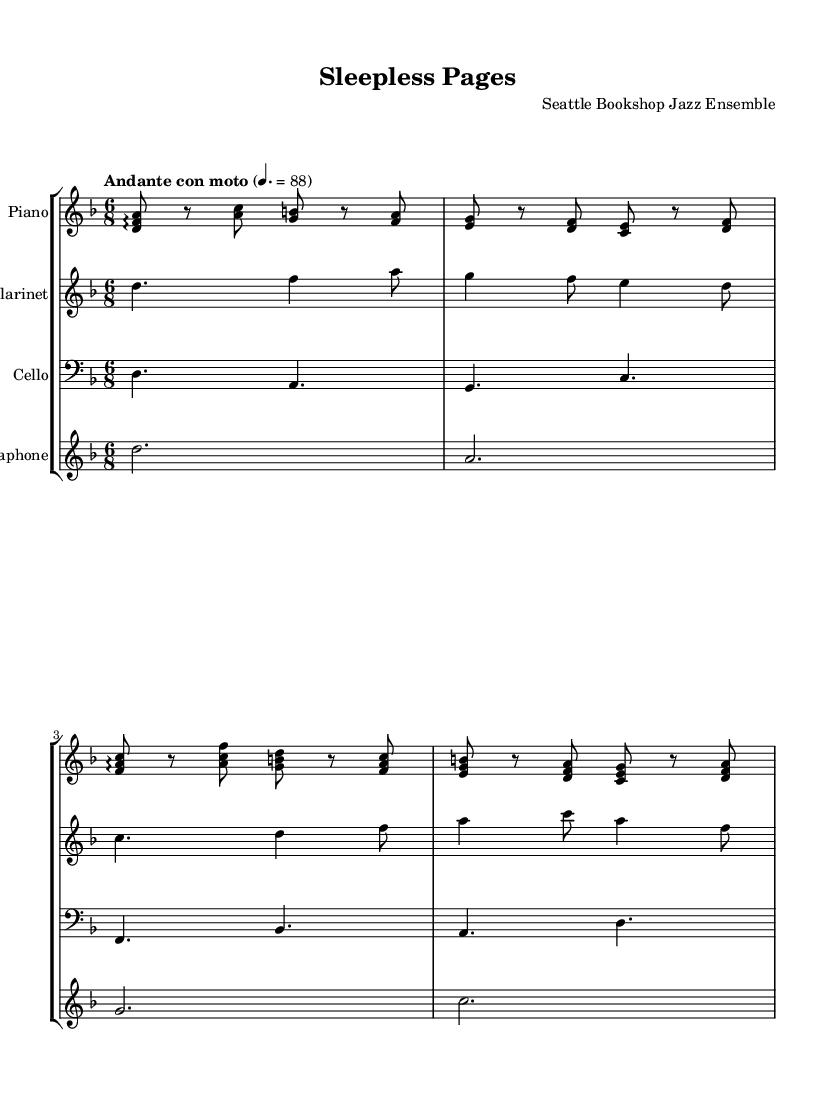What is the key signature of this music? The key signature shows one flat, indicating that the music is in the key of D minor.
Answer: D minor What is the time signature? The time signature is located at the beginning of the score and displayed as 6/8, indicating six eighth notes per measure.
Answer: 6/8 What is the tempo marking? The tempo marking is indicated above the staff and reads "Andante con moto," which means a moderately slow tempo with motion.
Answer: Andante con moto How many instruments are featured in this piece? The score includes four distinct staves, each representing a different instrument: piano, clarinet, cello, and vibraphone.
Answer: Four Which instrument has the highest pitch range? The clarinet is the highest-pitched instrument in the score, as it is written in the treble clef and plays notes in the upper register compared to the others.
Answer: Clarinet Which instrument plays the longest note duration? The vibraphone holds whole notes (dotted half notes) throughout its part, indicating it plays the longest sustained notes in the ensemble.
Answer: Vibraphone What texture does the music create with the specified instrumentation? The combination of instruments creates a lush, layered texture typical of jazz-classical fusion, where the piano provides harmonic support, the clarinet offers melodic lines, the cello plays bass, and the vibraphone adds color and rhythm.
Answer: Fusion texture 